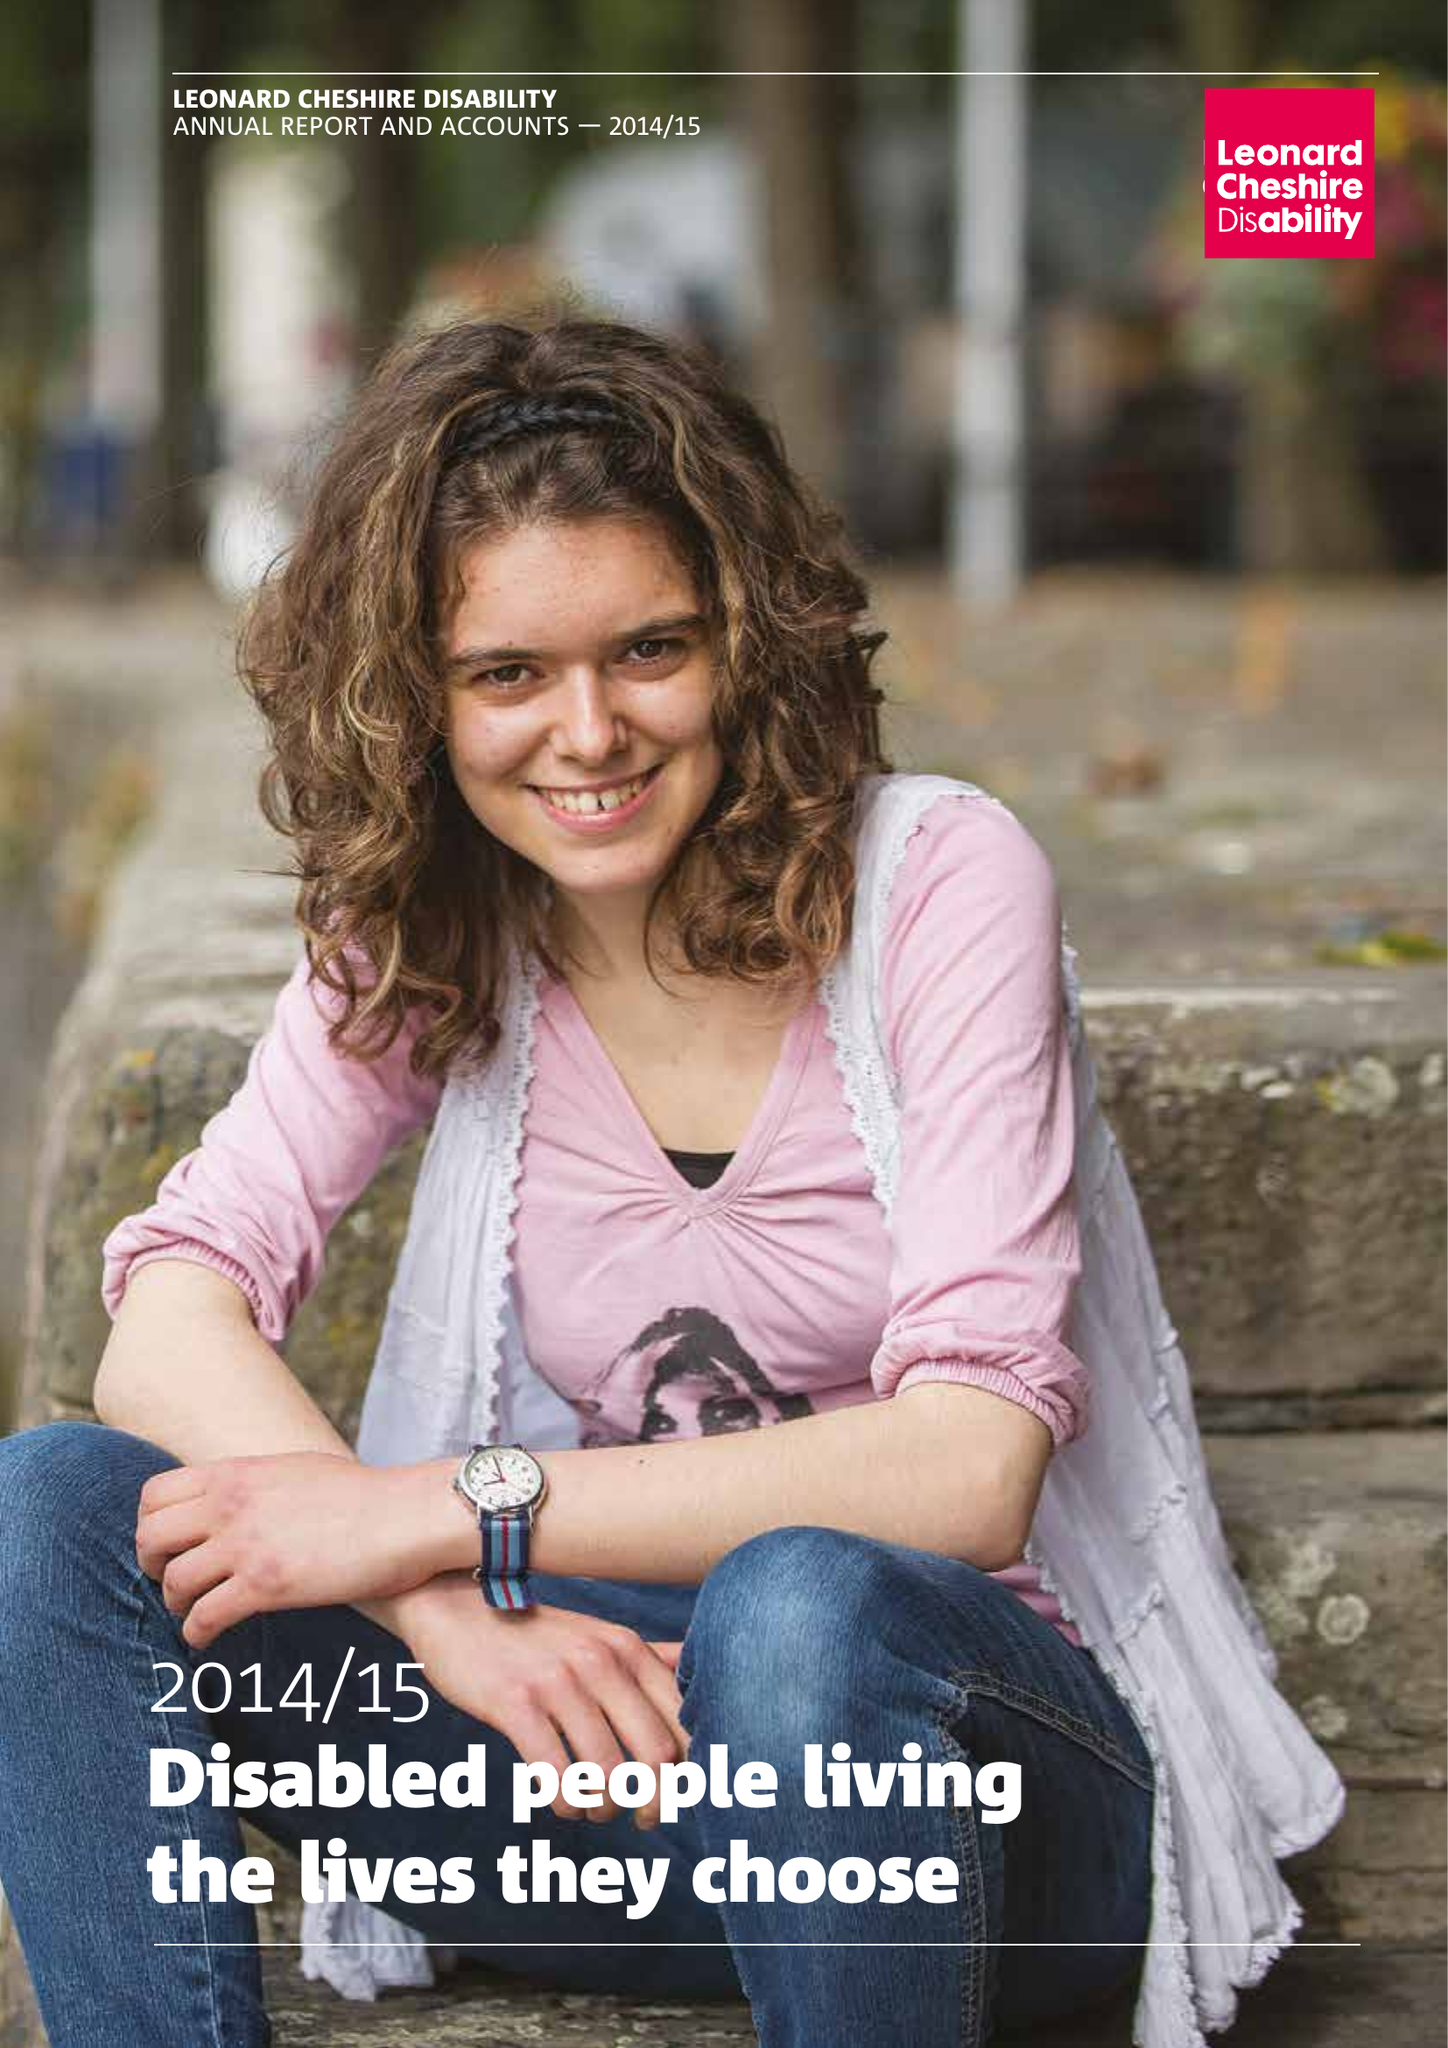What is the value for the address__street_line?
Answer the question using a single word or phrase. 66 SOUTH LAMBETH ROAD 